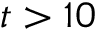Convert formula to latex. <formula><loc_0><loc_0><loc_500><loc_500>t > 1 0</formula> 